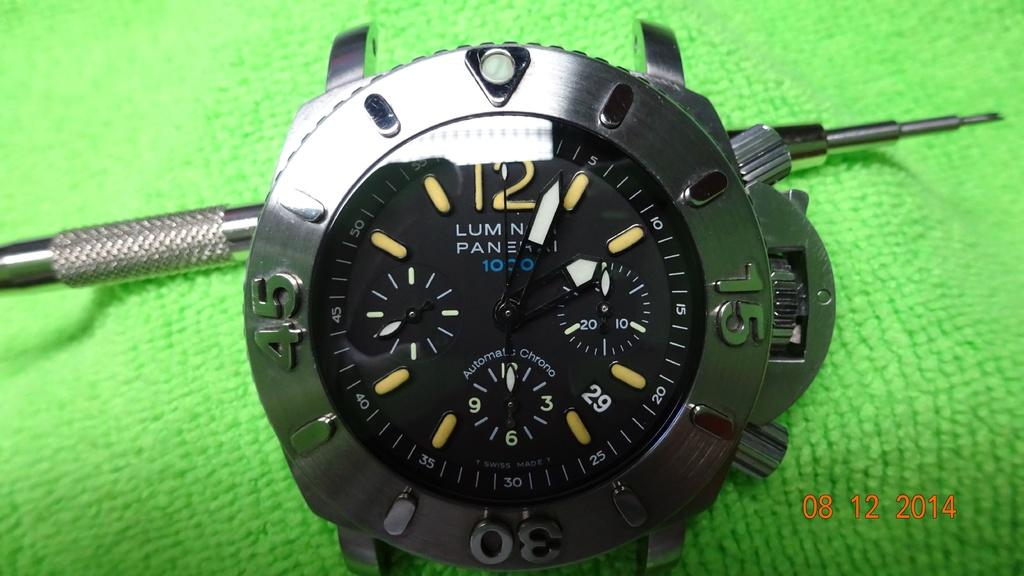<image>
Render a clear and concise summary of the photo. An Automatic Chrono watch is sitting on a bright green cloth. 